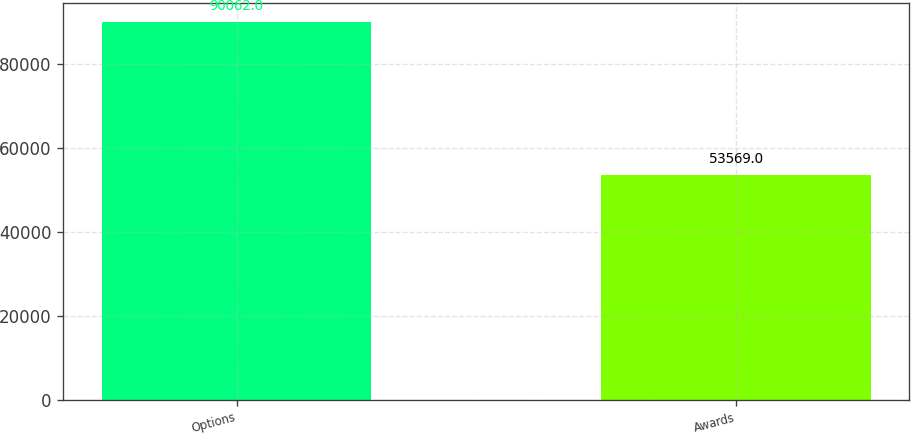Convert chart to OTSL. <chart><loc_0><loc_0><loc_500><loc_500><bar_chart><fcel>Options<fcel>Awards<nl><fcel>90062<fcel>53569<nl></chart> 